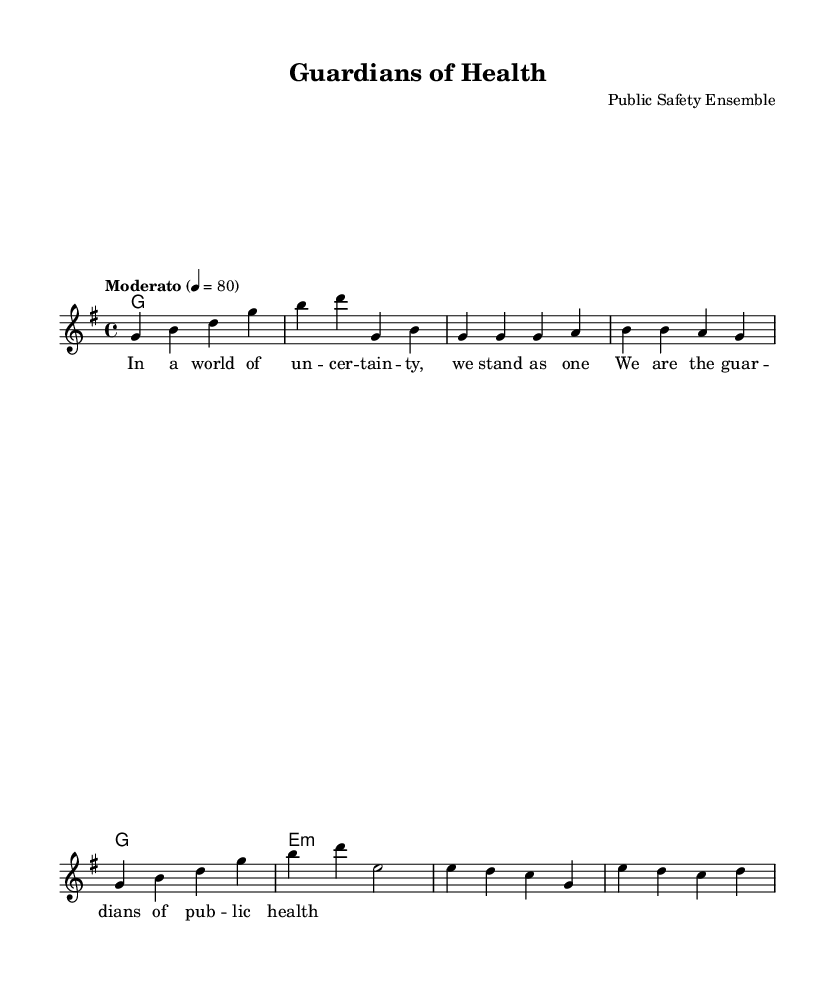What is the key signature of this music? The key signature is identified by the number of sharps or flats present at the beginning of the staff. In this piece, there are no sharps or flats indicated, which confirms that the key is G major.
Answer: G major What is the time signature of this music? The time signature is found at the beginning of the sheet music, represented by two numbers. Here, we see the 4/4 time signature, indicating that there are four beats per measure, and the quarter note gets one beat.
Answer: 4/4 What is the tempo marking for this piece? The tempo marking indicates the speed of the piece, and in this case, it is noted as "Moderato," with a metronome marking of 80 beats per minute, which suggests a moderate pace.
Answer: Moderato What is the primary theme addressed in the lyrics? The lyrics provided focus on the importance of public health and safety, as indicated by the phrases "guardians of public health" and the context of standing together in uncertain times.
Answer: Public health How many measures are in the chorus section? To determine the number of measures in the chorus section, we can count the individual measures from the score. The chorus is represented as having 2 measures in the provided lyrics.
Answer: 2 Which chord is used for the chorus? The chords accompanying the chorus can be found alongside the melody line, and during the chorus, the chord used is E minor, as indicated in the chord progression.
Answer: E minor What is the primary musical form shown in this piece? The form is deduced from the structure of the provided sections. It follows a common power ballad format with verses leading into a chorus, indicating a verse-chorus form typical for such songs.
Answer: Verse-chorus 